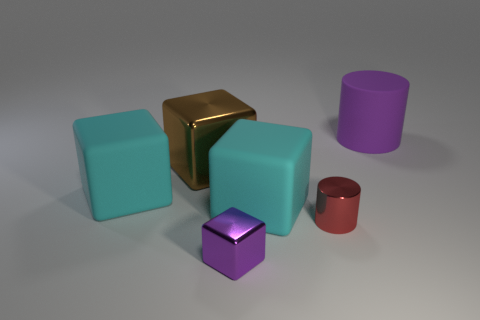Subtract all green cubes. Subtract all gray spheres. How many cubes are left? 4 Add 2 tiny blue metal objects. How many objects exist? 8 Subtract all cubes. How many objects are left? 2 Subtract 0 cyan balls. How many objects are left? 6 Subtract all red shiny objects. Subtract all small red cylinders. How many objects are left? 4 Add 2 big brown metal objects. How many big brown metal objects are left? 3 Add 3 large cyan blocks. How many large cyan blocks exist? 5 